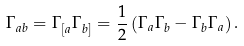<formula> <loc_0><loc_0><loc_500><loc_500>\Gamma _ { a b } = \Gamma _ { [ a } \Gamma _ { b ] } = \frac { 1 } { 2 } \left ( \Gamma _ { a } \Gamma _ { b } - \Gamma _ { b } \Gamma _ { a } \right ) .</formula> 